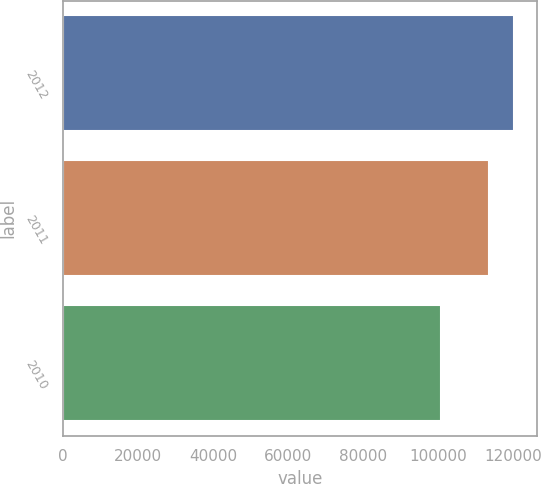Convert chart. <chart><loc_0><loc_0><loc_500><loc_500><bar_chart><fcel>2012<fcel>2011<fcel>2010<nl><fcel>120166<fcel>113405<fcel>100583<nl></chart> 